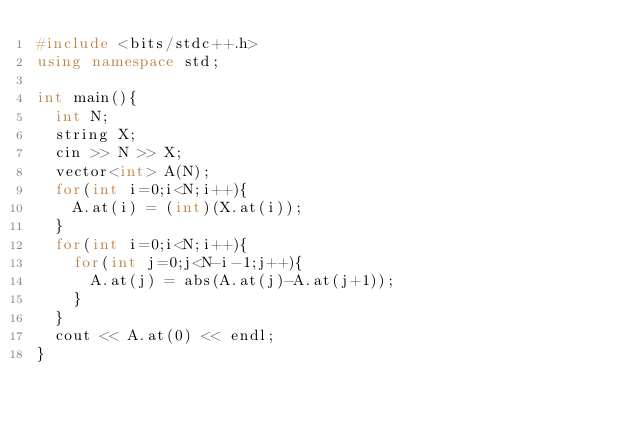Convert code to text. <code><loc_0><loc_0><loc_500><loc_500><_C++_>#include <bits/stdc++.h>
using namespace std;
 
int main(){
  int N;
  string X;
  cin >> N >> X;
  vector<int> A(N);
  for(int i=0;i<N;i++){
    A.at(i) = (int)(X.at(i));
  }
  for(int i=0;i<N;i++){
    for(int j=0;j<N-i-1;j++){
      A.at(j) = abs(A.at(j)-A.at(j+1));
    }
  }
  cout << A.at(0) << endl;
}</code> 